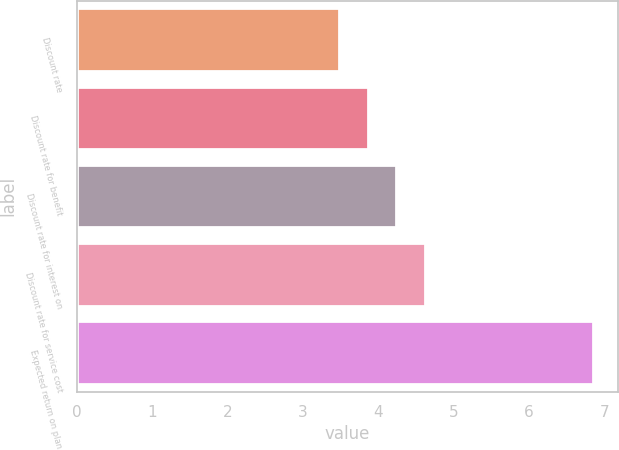Convert chart to OTSL. <chart><loc_0><loc_0><loc_500><loc_500><bar_chart><fcel>Discount rate<fcel>Discount rate for benefit<fcel>Discount rate for interest on<fcel>Discount rate for service cost<fcel>Expected return on plan<nl><fcel>3.48<fcel>3.86<fcel>4.24<fcel>4.62<fcel>6.84<nl></chart> 